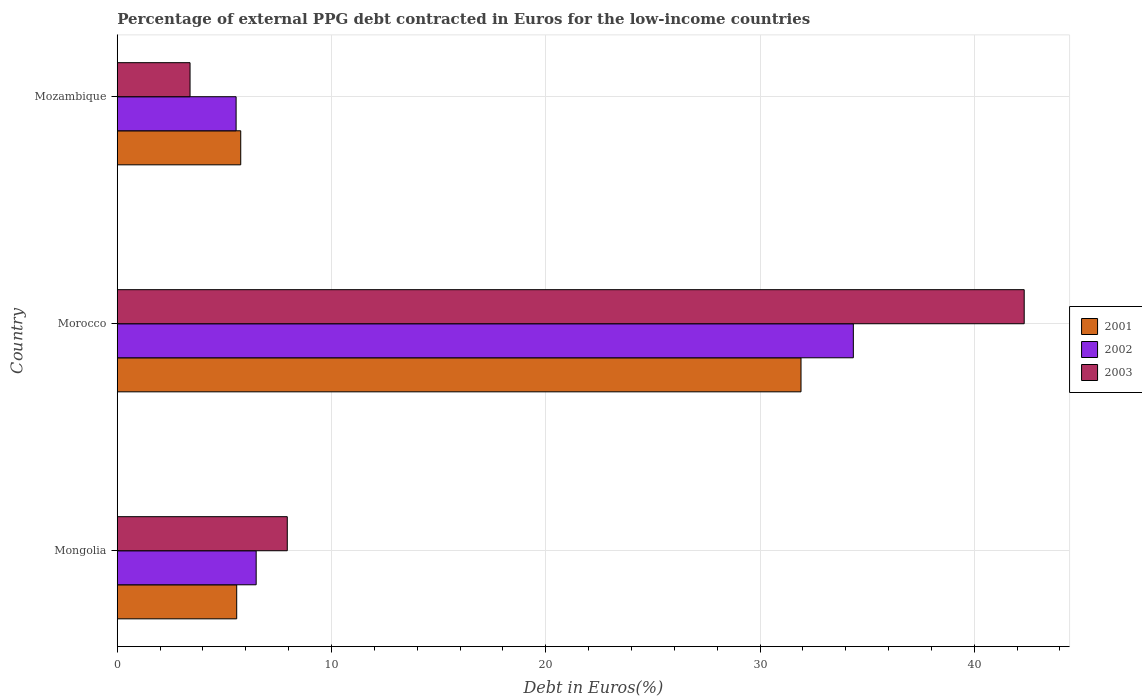Are the number of bars per tick equal to the number of legend labels?
Your response must be concise. Yes. How many bars are there on the 1st tick from the top?
Give a very brief answer. 3. How many bars are there on the 3rd tick from the bottom?
Offer a very short reply. 3. What is the label of the 1st group of bars from the top?
Provide a succinct answer. Mozambique. In how many cases, is the number of bars for a given country not equal to the number of legend labels?
Your answer should be compact. 0. What is the percentage of external PPG debt contracted in Euros in 2001 in Mozambique?
Provide a succinct answer. 5.76. Across all countries, what is the maximum percentage of external PPG debt contracted in Euros in 2003?
Keep it short and to the point. 42.33. Across all countries, what is the minimum percentage of external PPG debt contracted in Euros in 2003?
Keep it short and to the point. 3.4. In which country was the percentage of external PPG debt contracted in Euros in 2001 maximum?
Provide a succinct answer. Morocco. In which country was the percentage of external PPG debt contracted in Euros in 2001 minimum?
Ensure brevity in your answer.  Mongolia. What is the total percentage of external PPG debt contracted in Euros in 2002 in the graph?
Offer a very short reply. 46.39. What is the difference between the percentage of external PPG debt contracted in Euros in 2003 in Morocco and that in Mozambique?
Offer a terse response. 38.94. What is the difference between the percentage of external PPG debt contracted in Euros in 2001 in Mongolia and the percentage of external PPG debt contracted in Euros in 2003 in Mozambique?
Ensure brevity in your answer.  2.18. What is the average percentage of external PPG debt contracted in Euros in 2001 per country?
Ensure brevity in your answer.  14.42. What is the difference between the percentage of external PPG debt contracted in Euros in 2001 and percentage of external PPG debt contracted in Euros in 2003 in Morocco?
Provide a succinct answer. -10.42. What is the ratio of the percentage of external PPG debt contracted in Euros in 2001 in Mongolia to that in Morocco?
Keep it short and to the point. 0.17. What is the difference between the highest and the second highest percentage of external PPG debt contracted in Euros in 2001?
Offer a terse response. 26.15. What is the difference between the highest and the lowest percentage of external PPG debt contracted in Euros in 2002?
Offer a terse response. 28.81. In how many countries, is the percentage of external PPG debt contracted in Euros in 2001 greater than the average percentage of external PPG debt contracted in Euros in 2001 taken over all countries?
Ensure brevity in your answer.  1. Is the sum of the percentage of external PPG debt contracted in Euros in 2002 in Morocco and Mozambique greater than the maximum percentage of external PPG debt contracted in Euros in 2001 across all countries?
Your answer should be compact. Yes. What does the 1st bar from the top in Mongolia represents?
Provide a succinct answer. 2003. Is it the case that in every country, the sum of the percentage of external PPG debt contracted in Euros in 2001 and percentage of external PPG debt contracted in Euros in 2002 is greater than the percentage of external PPG debt contracted in Euros in 2003?
Offer a terse response. Yes. What is the difference between two consecutive major ticks on the X-axis?
Offer a terse response. 10. Does the graph contain any zero values?
Keep it short and to the point. No. Where does the legend appear in the graph?
Provide a short and direct response. Center right. How are the legend labels stacked?
Keep it short and to the point. Vertical. What is the title of the graph?
Give a very brief answer. Percentage of external PPG debt contracted in Euros for the low-income countries. What is the label or title of the X-axis?
Keep it short and to the point. Debt in Euros(%). What is the Debt in Euros(%) in 2001 in Mongolia?
Offer a very short reply. 5.57. What is the Debt in Euros(%) in 2002 in Mongolia?
Make the answer very short. 6.48. What is the Debt in Euros(%) in 2003 in Mongolia?
Ensure brevity in your answer.  7.93. What is the Debt in Euros(%) of 2001 in Morocco?
Offer a terse response. 31.91. What is the Debt in Euros(%) of 2002 in Morocco?
Your answer should be compact. 34.36. What is the Debt in Euros(%) of 2003 in Morocco?
Give a very brief answer. 42.33. What is the Debt in Euros(%) in 2001 in Mozambique?
Keep it short and to the point. 5.76. What is the Debt in Euros(%) of 2002 in Mozambique?
Keep it short and to the point. 5.55. What is the Debt in Euros(%) in 2003 in Mozambique?
Your answer should be very brief. 3.4. Across all countries, what is the maximum Debt in Euros(%) in 2001?
Your response must be concise. 31.91. Across all countries, what is the maximum Debt in Euros(%) of 2002?
Your answer should be compact. 34.36. Across all countries, what is the maximum Debt in Euros(%) in 2003?
Your answer should be very brief. 42.33. Across all countries, what is the minimum Debt in Euros(%) in 2001?
Give a very brief answer. 5.57. Across all countries, what is the minimum Debt in Euros(%) of 2002?
Keep it short and to the point. 5.55. Across all countries, what is the minimum Debt in Euros(%) in 2003?
Your answer should be compact. 3.4. What is the total Debt in Euros(%) in 2001 in the graph?
Give a very brief answer. 43.25. What is the total Debt in Euros(%) of 2002 in the graph?
Offer a very short reply. 46.39. What is the total Debt in Euros(%) of 2003 in the graph?
Provide a short and direct response. 53.66. What is the difference between the Debt in Euros(%) of 2001 in Mongolia and that in Morocco?
Ensure brevity in your answer.  -26.34. What is the difference between the Debt in Euros(%) of 2002 in Mongolia and that in Morocco?
Make the answer very short. -27.87. What is the difference between the Debt in Euros(%) in 2003 in Mongolia and that in Morocco?
Your answer should be compact. -34.4. What is the difference between the Debt in Euros(%) in 2001 in Mongolia and that in Mozambique?
Make the answer very short. -0.19. What is the difference between the Debt in Euros(%) of 2002 in Mongolia and that in Mozambique?
Your response must be concise. 0.94. What is the difference between the Debt in Euros(%) of 2003 in Mongolia and that in Mozambique?
Ensure brevity in your answer.  4.54. What is the difference between the Debt in Euros(%) of 2001 in Morocco and that in Mozambique?
Your response must be concise. 26.15. What is the difference between the Debt in Euros(%) of 2002 in Morocco and that in Mozambique?
Offer a very short reply. 28.81. What is the difference between the Debt in Euros(%) in 2003 in Morocco and that in Mozambique?
Offer a terse response. 38.94. What is the difference between the Debt in Euros(%) in 2001 in Mongolia and the Debt in Euros(%) in 2002 in Morocco?
Provide a succinct answer. -28.78. What is the difference between the Debt in Euros(%) of 2001 in Mongolia and the Debt in Euros(%) of 2003 in Morocco?
Your answer should be compact. -36.76. What is the difference between the Debt in Euros(%) in 2002 in Mongolia and the Debt in Euros(%) in 2003 in Morocco?
Provide a short and direct response. -35.85. What is the difference between the Debt in Euros(%) in 2001 in Mongolia and the Debt in Euros(%) in 2002 in Mozambique?
Ensure brevity in your answer.  0.03. What is the difference between the Debt in Euros(%) in 2001 in Mongolia and the Debt in Euros(%) in 2003 in Mozambique?
Ensure brevity in your answer.  2.18. What is the difference between the Debt in Euros(%) of 2002 in Mongolia and the Debt in Euros(%) of 2003 in Mozambique?
Provide a short and direct response. 3.09. What is the difference between the Debt in Euros(%) in 2001 in Morocco and the Debt in Euros(%) in 2002 in Mozambique?
Your answer should be very brief. 26.37. What is the difference between the Debt in Euros(%) of 2001 in Morocco and the Debt in Euros(%) of 2003 in Mozambique?
Your answer should be compact. 28.52. What is the difference between the Debt in Euros(%) in 2002 in Morocco and the Debt in Euros(%) in 2003 in Mozambique?
Make the answer very short. 30.96. What is the average Debt in Euros(%) of 2001 per country?
Offer a very short reply. 14.42. What is the average Debt in Euros(%) in 2002 per country?
Ensure brevity in your answer.  15.46. What is the average Debt in Euros(%) of 2003 per country?
Give a very brief answer. 17.89. What is the difference between the Debt in Euros(%) in 2001 and Debt in Euros(%) in 2002 in Mongolia?
Your answer should be very brief. -0.91. What is the difference between the Debt in Euros(%) of 2001 and Debt in Euros(%) of 2003 in Mongolia?
Ensure brevity in your answer.  -2.36. What is the difference between the Debt in Euros(%) of 2002 and Debt in Euros(%) of 2003 in Mongolia?
Your answer should be very brief. -1.45. What is the difference between the Debt in Euros(%) of 2001 and Debt in Euros(%) of 2002 in Morocco?
Offer a terse response. -2.44. What is the difference between the Debt in Euros(%) in 2001 and Debt in Euros(%) in 2003 in Morocco?
Make the answer very short. -10.42. What is the difference between the Debt in Euros(%) of 2002 and Debt in Euros(%) of 2003 in Morocco?
Keep it short and to the point. -7.98. What is the difference between the Debt in Euros(%) of 2001 and Debt in Euros(%) of 2002 in Mozambique?
Offer a very short reply. 0.22. What is the difference between the Debt in Euros(%) of 2001 and Debt in Euros(%) of 2003 in Mozambique?
Your answer should be very brief. 2.37. What is the difference between the Debt in Euros(%) of 2002 and Debt in Euros(%) of 2003 in Mozambique?
Give a very brief answer. 2.15. What is the ratio of the Debt in Euros(%) of 2001 in Mongolia to that in Morocco?
Your response must be concise. 0.17. What is the ratio of the Debt in Euros(%) in 2002 in Mongolia to that in Morocco?
Make the answer very short. 0.19. What is the ratio of the Debt in Euros(%) in 2003 in Mongolia to that in Morocco?
Keep it short and to the point. 0.19. What is the ratio of the Debt in Euros(%) of 2001 in Mongolia to that in Mozambique?
Offer a very short reply. 0.97. What is the ratio of the Debt in Euros(%) of 2002 in Mongolia to that in Mozambique?
Keep it short and to the point. 1.17. What is the ratio of the Debt in Euros(%) in 2003 in Mongolia to that in Mozambique?
Ensure brevity in your answer.  2.34. What is the ratio of the Debt in Euros(%) of 2001 in Morocco to that in Mozambique?
Offer a very short reply. 5.54. What is the ratio of the Debt in Euros(%) of 2002 in Morocco to that in Mozambique?
Give a very brief answer. 6.19. What is the ratio of the Debt in Euros(%) of 2003 in Morocco to that in Mozambique?
Your answer should be compact. 12.46. What is the difference between the highest and the second highest Debt in Euros(%) of 2001?
Make the answer very short. 26.15. What is the difference between the highest and the second highest Debt in Euros(%) of 2002?
Your answer should be compact. 27.87. What is the difference between the highest and the second highest Debt in Euros(%) in 2003?
Keep it short and to the point. 34.4. What is the difference between the highest and the lowest Debt in Euros(%) of 2001?
Ensure brevity in your answer.  26.34. What is the difference between the highest and the lowest Debt in Euros(%) of 2002?
Your response must be concise. 28.81. What is the difference between the highest and the lowest Debt in Euros(%) of 2003?
Make the answer very short. 38.94. 